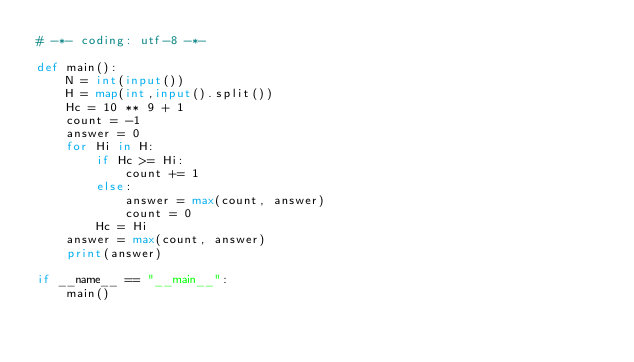<code> <loc_0><loc_0><loc_500><loc_500><_Python_># -*- coding: utf-8 -*-

def main():
    N = int(input())
    H = map(int,input().split())
    Hc = 10 ** 9 + 1
    count = -1
    answer = 0
    for Hi in H:
        if Hc >= Hi:
            count += 1
        else:
            answer = max(count, answer)
            count = 0
        Hc = Hi
    answer = max(count, answer)
    print(answer)

if __name__ == "__main__":
    main()
</code> 